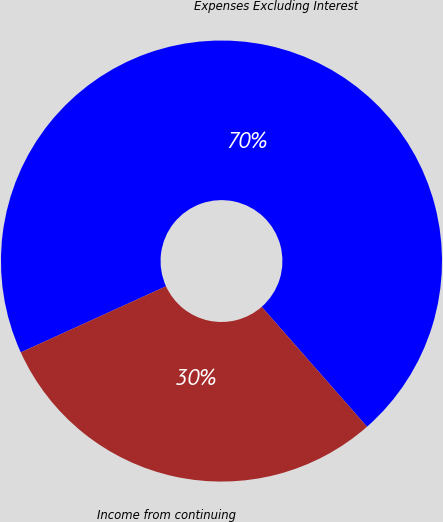Convert chart to OTSL. <chart><loc_0><loc_0><loc_500><loc_500><pie_chart><fcel>Expenses Excluding Interest<fcel>Income from continuing<nl><fcel>70.33%<fcel>29.67%<nl></chart> 